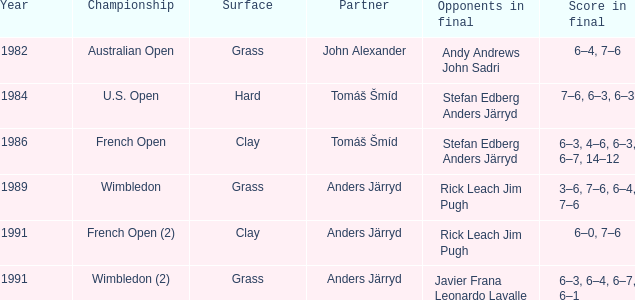Who was his partner in 1989?  Anders Järryd. 